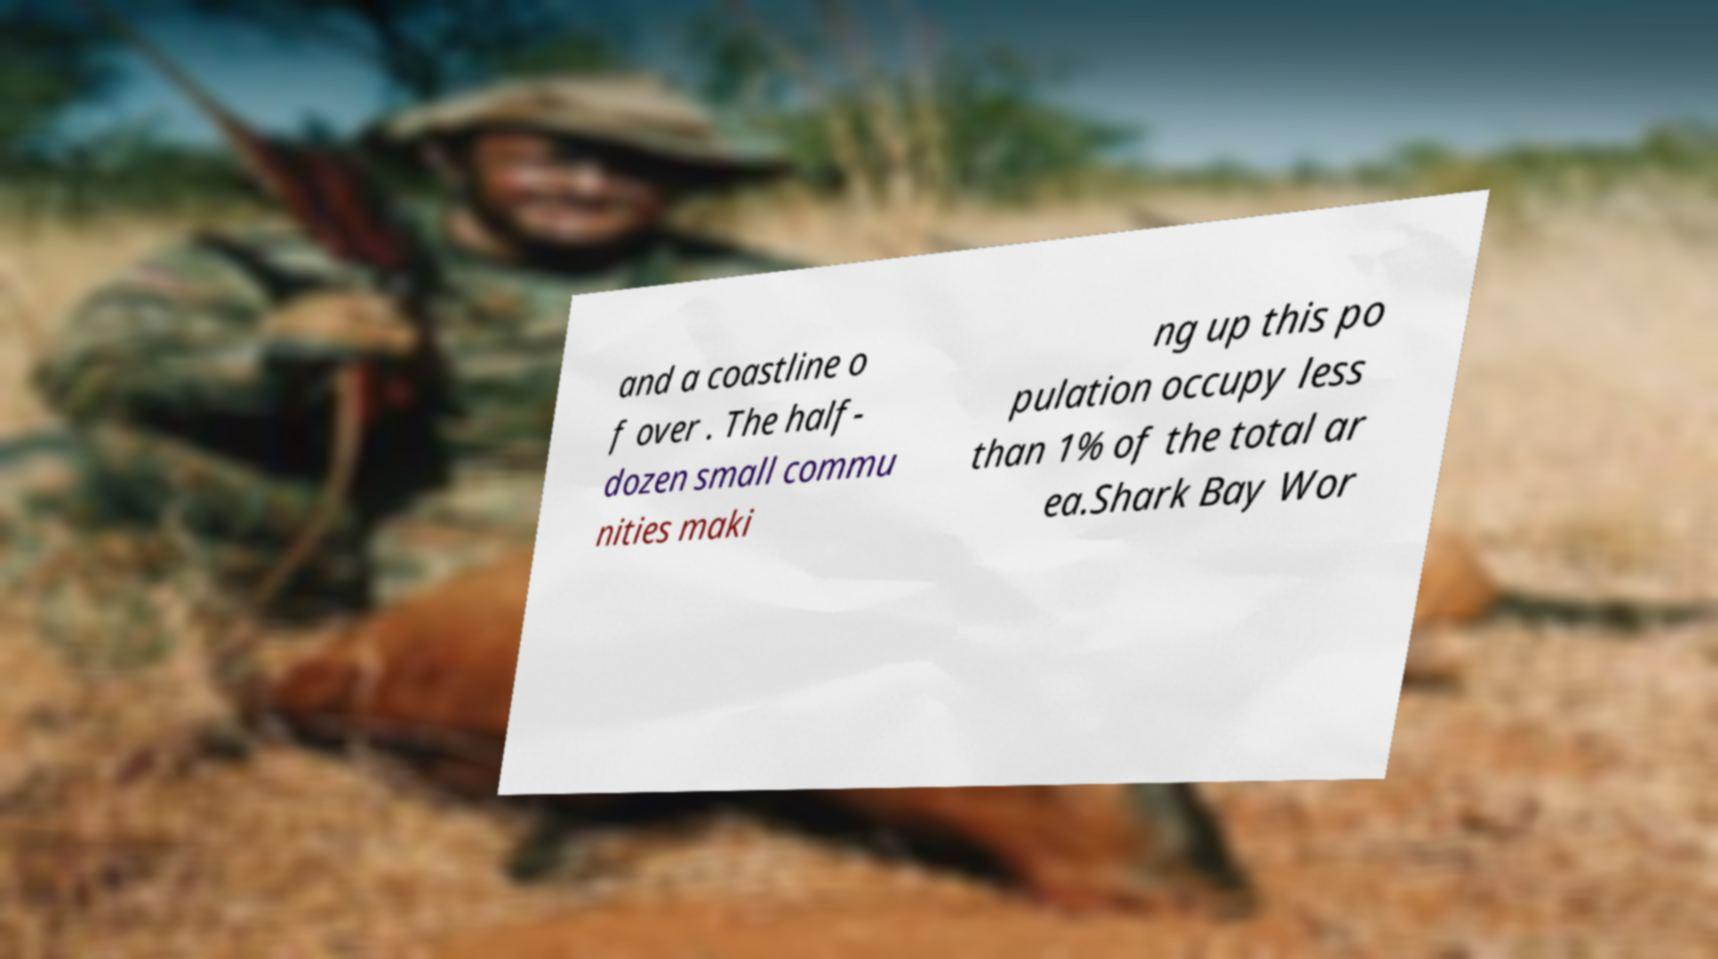I need the written content from this picture converted into text. Can you do that? and a coastline o f over . The half- dozen small commu nities maki ng up this po pulation occupy less than 1% of the total ar ea.Shark Bay Wor 